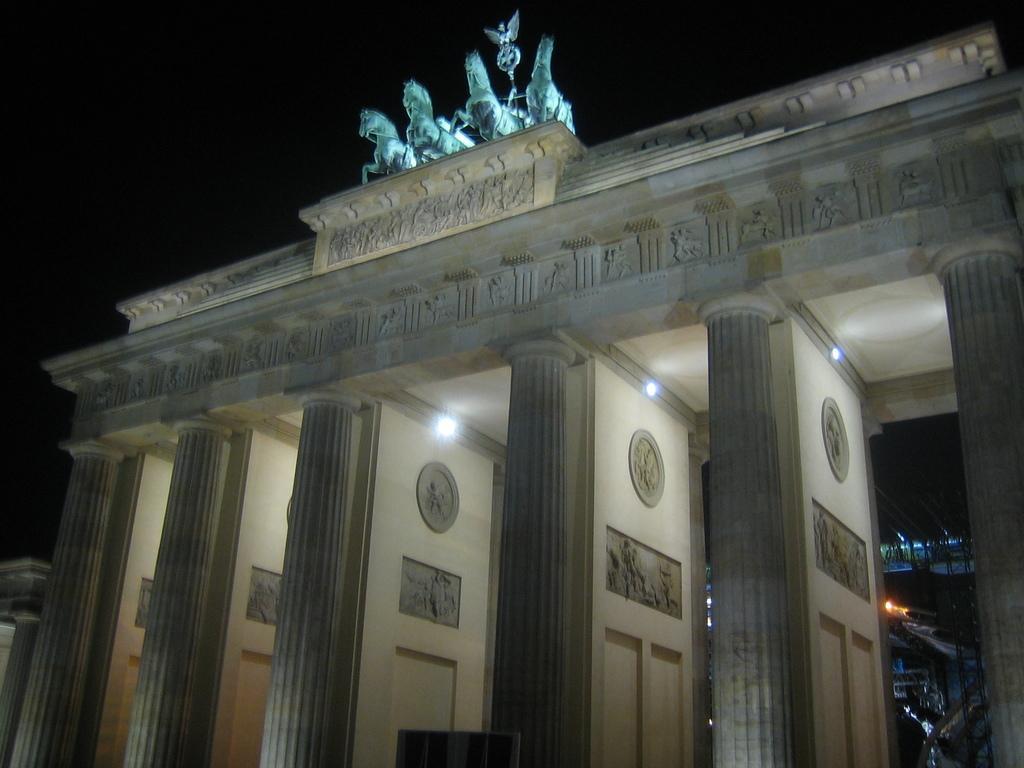How would you summarize this image in a sentence or two? In the picture we can see a gateway of the palace, which is white in color with architect to it and on the top of it, we can see some horse sculptures and behind it we can see the sky which is dark. 